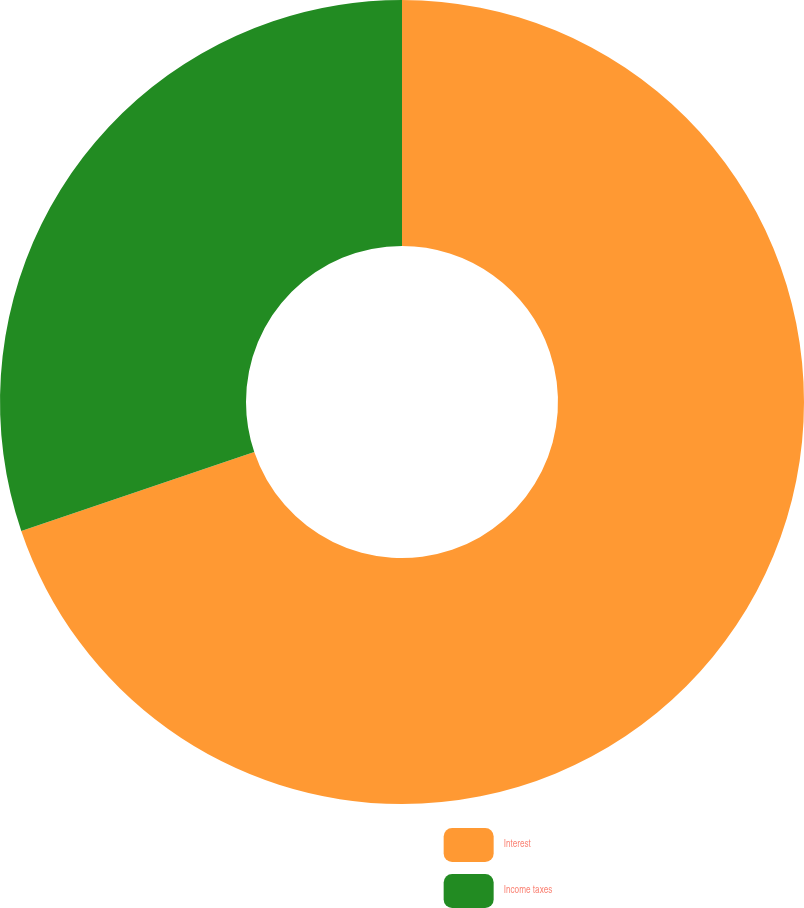<chart> <loc_0><loc_0><loc_500><loc_500><pie_chart><fcel>Interest<fcel>Income taxes<nl><fcel>69.8%<fcel>30.2%<nl></chart> 